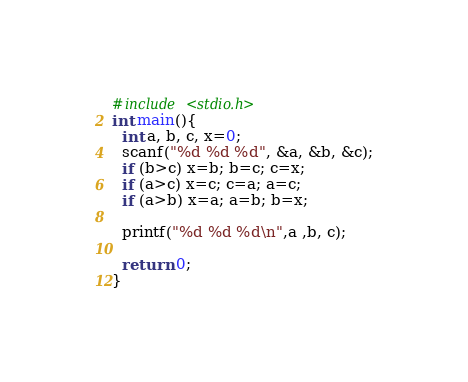Convert code to text. <code><loc_0><loc_0><loc_500><loc_500><_C_>#include <stdio.h>
int main(){
  int a, b, c, x=0;
  scanf("%d %d %d", &a, &b, &c);
  if (b>c) x=b; b=c; c=x;
  if (a>c) x=c; c=a; a=c;
  if (a>b) x=a; a=b; b=x;

  printf("%d %d %d\n",a ,b, c);

  return 0;
}</code> 